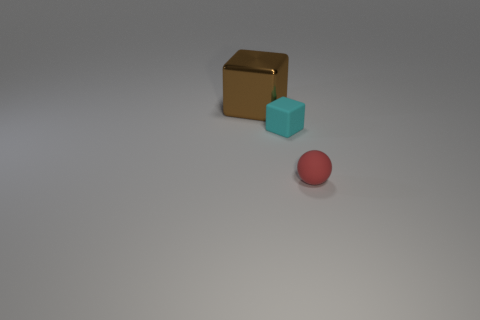Subtract all blocks. How many objects are left? 1 Add 3 brown metallic objects. How many objects exist? 6 Subtract 0 green cubes. How many objects are left? 3 Subtract all purple blocks. Subtract all brown cylinders. How many blocks are left? 2 Subtract all large gray matte blocks. Subtract all small objects. How many objects are left? 1 Add 1 brown cubes. How many brown cubes are left? 2 Add 3 red objects. How many red objects exist? 4 